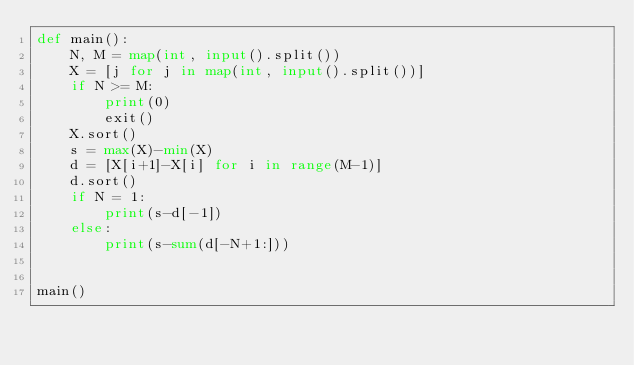<code> <loc_0><loc_0><loc_500><loc_500><_Python_>def main():
    N, M = map(int, input().split())
    X = [j for j in map(int, input().split())]
    if N >= M:
        print(0)
        exit()
    X.sort()
    s = max(X)-min(X)
    d = [X[i+1]-X[i] for i in range(M-1)]
    d.sort()
    if N = 1:
        print(s-d[-1])
    else:
        print(s-sum(d[-N+1:]))


main()
</code> 